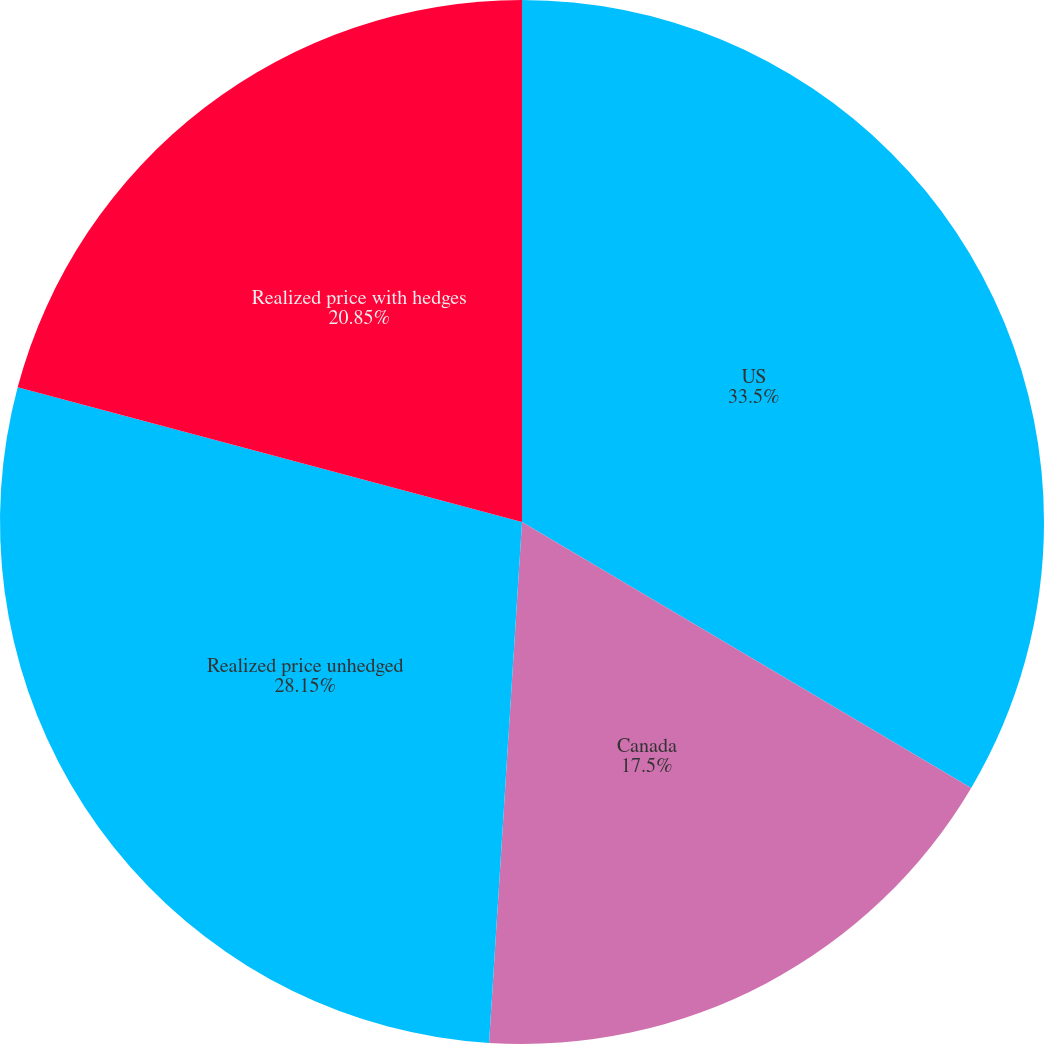<chart> <loc_0><loc_0><loc_500><loc_500><pie_chart><fcel>US<fcel>Canada<fcel>Realized price unhedged<fcel>Realized price with hedges<nl><fcel>33.51%<fcel>17.5%<fcel>28.15%<fcel>20.85%<nl></chart> 